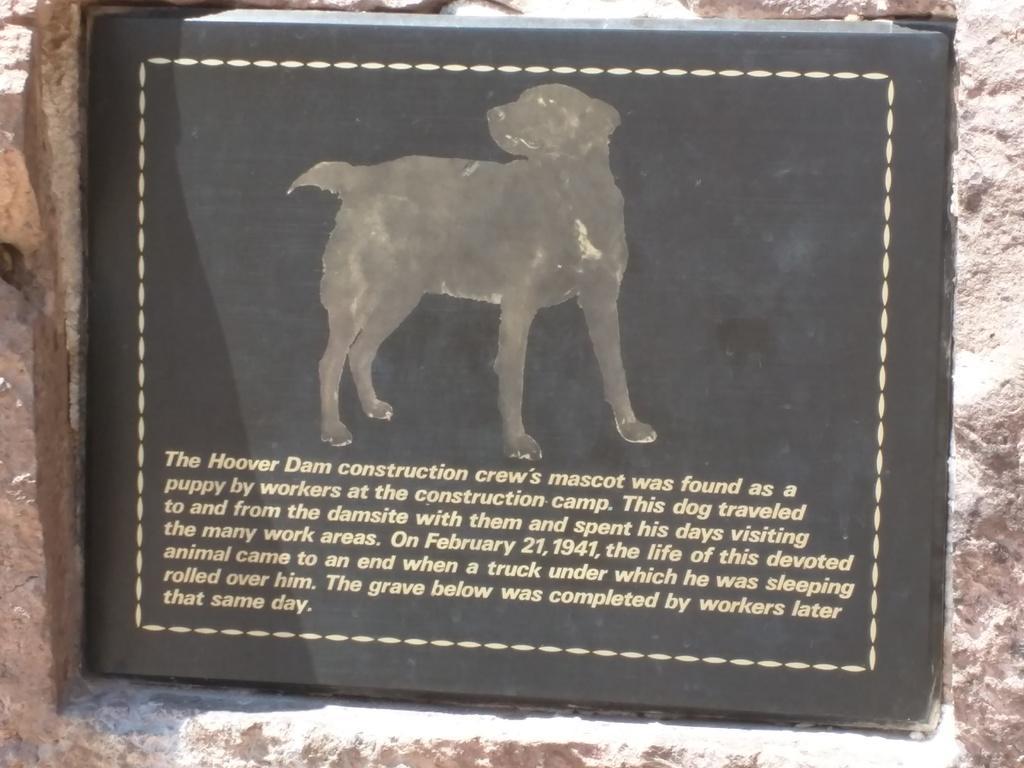Please provide a concise description of this image. In the picture we can see a grave of the dog with a black color plate on it we can see a image of a dog and some lines written about the dog under it. 